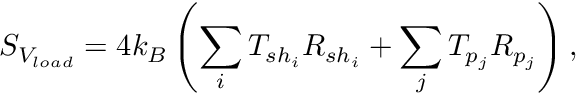Convert formula to latex. <formula><loc_0><loc_0><loc_500><loc_500>S _ { V _ { l o a d } } = 4 k _ { B } \left ( \sum _ { i } T _ { s h _ { i } } R _ { s h _ { i } } + \sum _ { j } T _ { p _ { j } } R _ { p _ { j } } \right ) ,</formula> 